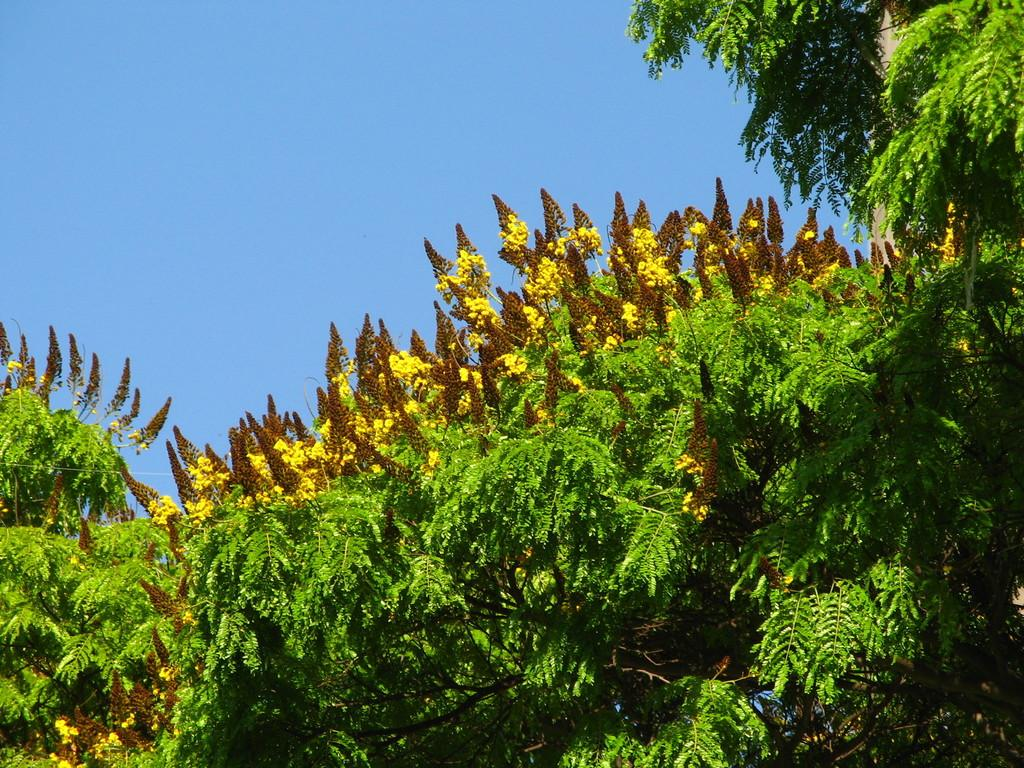What type of vegetation can be seen in the image? There are trees in the image. Are there any specific features of the trees? Yes, there are yellow flowers on the trees. What can be seen in the background of the image? The sky is visible in the background of the image. Where is the note placed on the tree in the image? There is no note present in the image; it only features trees with yellow flowers. What type of bead can be seen hanging from the branches in the image? There are no beads present in the image; it only features trees with yellow flowers. 